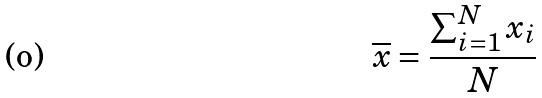Convert formula to latex. <formula><loc_0><loc_0><loc_500><loc_500>\overline { x } = \frac { \sum _ { i = 1 } ^ { N } x _ { i } } { N }</formula> 